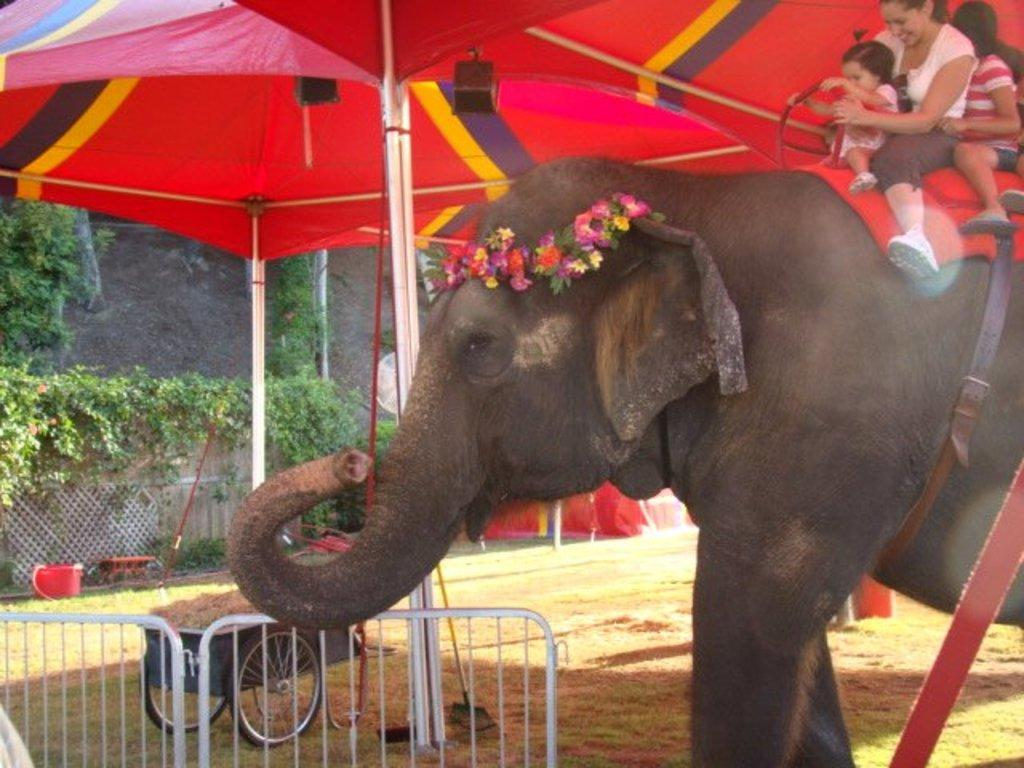What is the main subject of the image? The main subject of the image is people sitting on an elephant. What decorations are on the elephant? There are colorful flowers on the elephant's head. What is in front of the elephant? There is a fencing, trees, umbrellas, a vehicle, and a wall in front of the elephant. What type of cakes are being served to the people sitting on the elephant? There are no cakes present in the image; the people are sitting on an elephant with colorful flowers on its head. Can you tell me what the aunt of the person sitting on the elephant is doing in the image? There is no mention of an aunt or any person sitting on the elephant in the provided facts, so it cannot be determined from the image. --- Facts: 1. There is a person holding a camera in the image. 2. The person is standing on a bridge. 3. There is a river below the bridge. 4. There are trees on both sides of the river. 5. The sky is visible in the image. Absurd Topics: parrot, bicycle, shoes Conversation: What is the person in the image holding? The person in the image is holding a camera. Where is the person standing in the image? The person is standing on a bridge. What can be seen below the bridge? There is a river below the bridge. What type of vegetation is present near the river? There are trees on both sides of the river. What is visible in the sky in the image? The sky is visible in the image. Reasoning: Let's think step by step in order to produce the conversation. We start by identifying the main subject of the image, which is the person holding a camera. Then, we describe the location of the person, which is on a bridge. Next, we mention the river below the bridge and the trees on both sides of the river. Finally, we acknowledge the presence of the sky in the image. Absurd Question/Answer: Can you tell me how many parrots are sitting on the person's shoulder in the image? There are no parrots present in the image; the person is holding a camera while standing on a bridge. What type of shoes is the person wearing in the image? There is no mention of shoes or any footwear in the provided facts, so it cannot be determined from the image. 